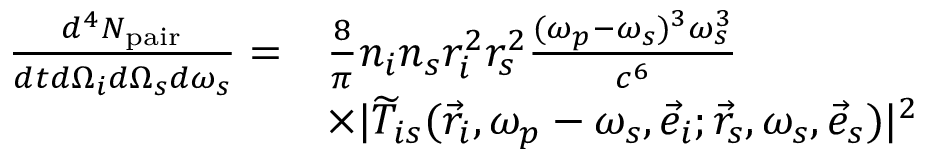Convert formula to latex. <formula><loc_0><loc_0><loc_500><loc_500>\begin{array} { r l } { \frac { d ^ { 4 } N _ { p a i r } } { d t d \Omega _ { i } d \Omega _ { s } d \omega _ { s } } = } & { \frac { 8 } { \pi } n _ { i } n _ { s } r _ { i } ^ { 2 } r _ { s } ^ { 2 } \frac { ( \omega _ { p } - \omega _ { s } ) ^ { 3 } \omega _ { s } ^ { 3 } } { c ^ { 6 } } } \\ & { \times | \widetilde { T } _ { i s } ( \vec { r } _ { i } , \omega _ { p } - \omega _ { s } , \vec { e } _ { i } ; \vec { r } _ { s } , \omega _ { s } , \vec { e } _ { s } ) | ^ { 2 } } \end{array}</formula> 